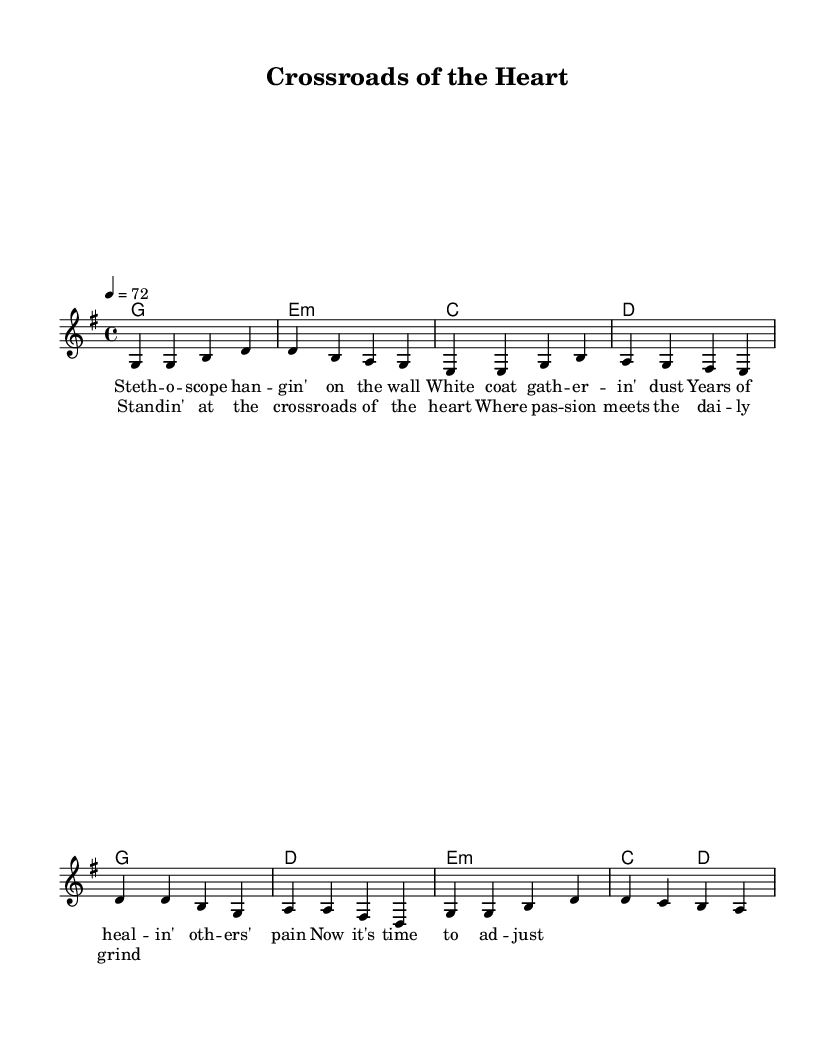What is the key signature of this music? The key signature is G major, which has one sharp (F#). This can be determined from the initial part of the sheet music where the key signature is indicated.
Answer: G major What is the time signature of this music? The time signature is 4/4, which means there are four beats in each measure and the quarter note gets one beat. This is visible in the score as "4/4" is noted before the beginning of the melody.
Answer: 4/4 What is the tempo marking for this piece? The tempo marking is 72 beats per minute, indicated by the tempo instruction "4 = 72" at the beginning of the score, which specifies how fast the piece should be played.
Answer: 72 How many bars are in the verse section? The verse consists of four bars as each line of the melody corresponds to a bar, which can be verified by counting the measures in the melody section provided.
Answer: 4 What is the first word of the chorus? The first word of the chorus is "Stan," which is the first lyric in the chorus section highlighted in the lyrics portion of the sheet music.
Answer: Stan In which section do we see the chord G in the harmonies? The chord G appears in the harmonies during both the verse and chorus sections, specifically noted at the beginning of each section as the first harmony.
Answer: Verse and Chorus What is the main theme of this song based on the lyrics? The main theme revolves around career transitions and work-life balance, as suggested by the lyrics regarding a stethoscope and adjusting to new paths in life. This theme is conveyed through the contrasting imagery of a medical profession and personal choices.
Answer: Career transitions 